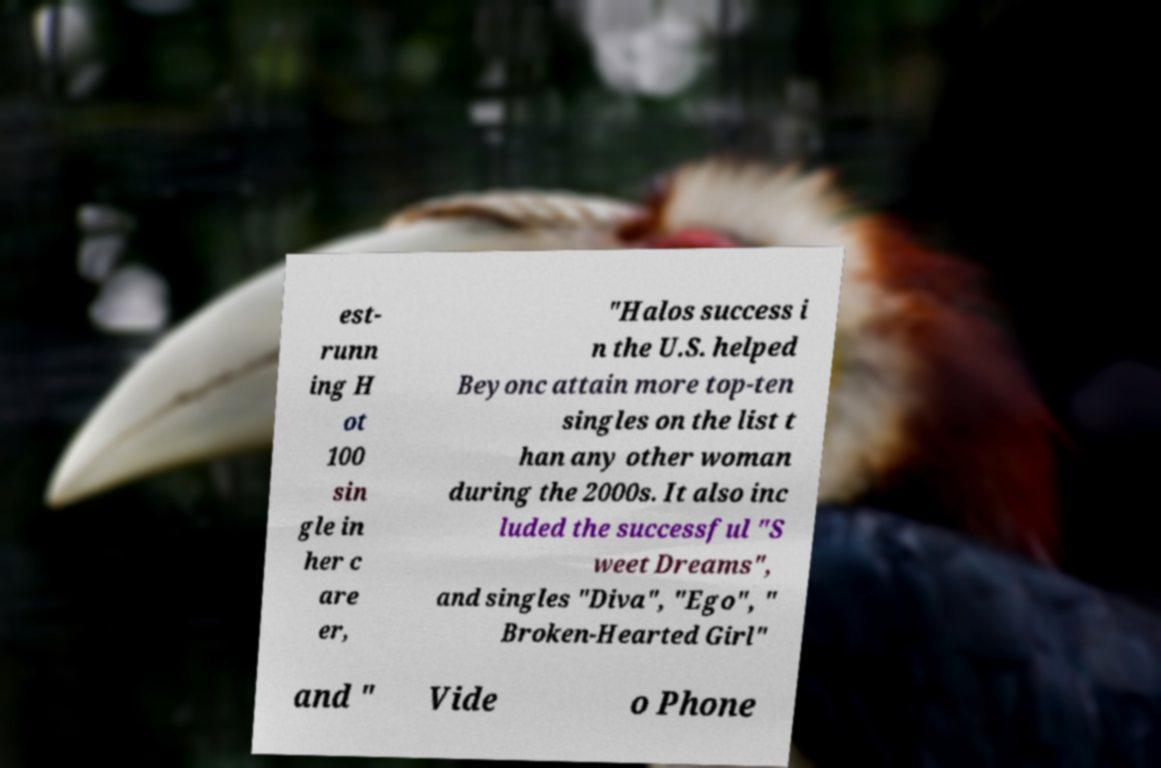For documentation purposes, I need the text within this image transcribed. Could you provide that? est- runn ing H ot 100 sin gle in her c are er, "Halos success i n the U.S. helped Beyonc attain more top-ten singles on the list t han any other woman during the 2000s. It also inc luded the successful "S weet Dreams", and singles "Diva", "Ego", " Broken-Hearted Girl" and " Vide o Phone 